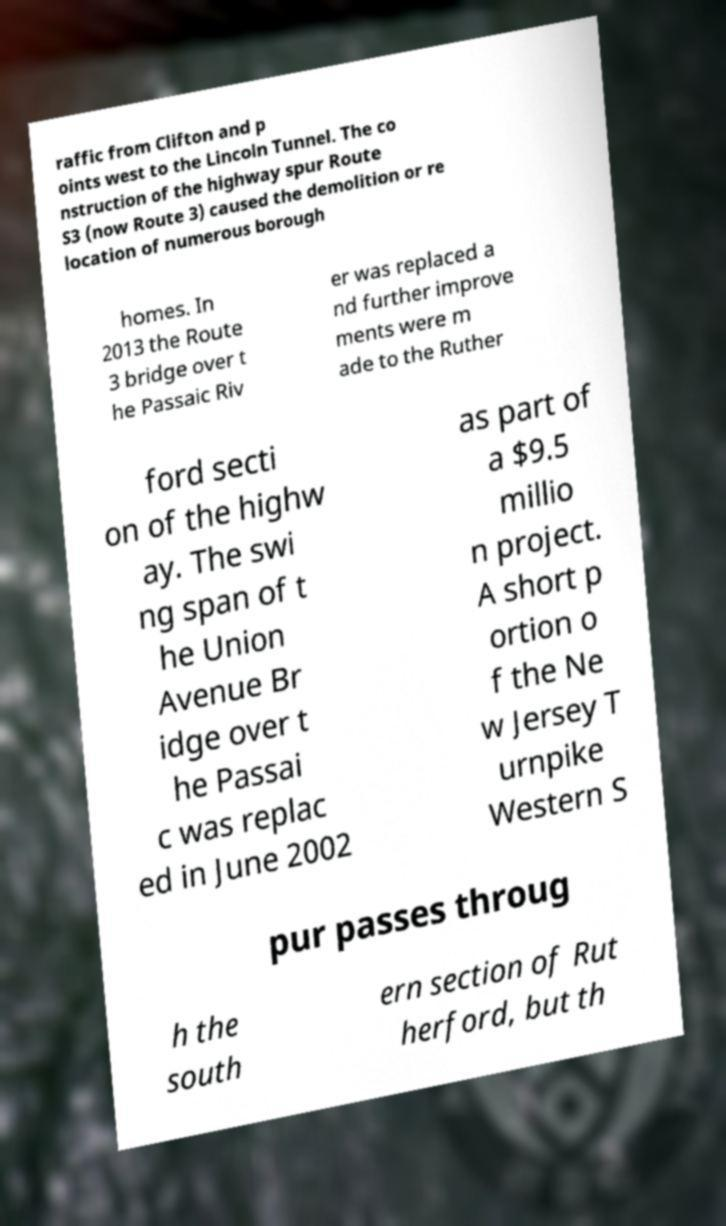Can you read and provide the text displayed in the image?This photo seems to have some interesting text. Can you extract and type it out for me? raffic from Clifton and p oints west to the Lincoln Tunnel. The co nstruction of the highway spur Route S3 (now Route 3) caused the demolition or re location of numerous borough homes. In 2013 the Route 3 bridge over t he Passaic Riv er was replaced a nd further improve ments were m ade to the Ruther ford secti on of the highw ay. The swi ng span of t he Union Avenue Br idge over t he Passai c was replac ed in June 2002 as part of a $9.5 millio n project. A short p ortion o f the Ne w Jersey T urnpike Western S pur passes throug h the south ern section of Rut herford, but th 